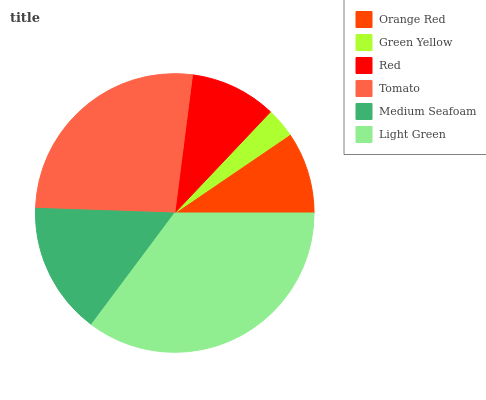Is Green Yellow the minimum?
Answer yes or no. Yes. Is Light Green the maximum?
Answer yes or no. Yes. Is Red the minimum?
Answer yes or no. No. Is Red the maximum?
Answer yes or no. No. Is Red greater than Green Yellow?
Answer yes or no. Yes. Is Green Yellow less than Red?
Answer yes or no. Yes. Is Green Yellow greater than Red?
Answer yes or no. No. Is Red less than Green Yellow?
Answer yes or no. No. Is Medium Seafoam the high median?
Answer yes or no. Yes. Is Red the low median?
Answer yes or no. Yes. Is Tomato the high median?
Answer yes or no. No. Is Green Yellow the low median?
Answer yes or no. No. 